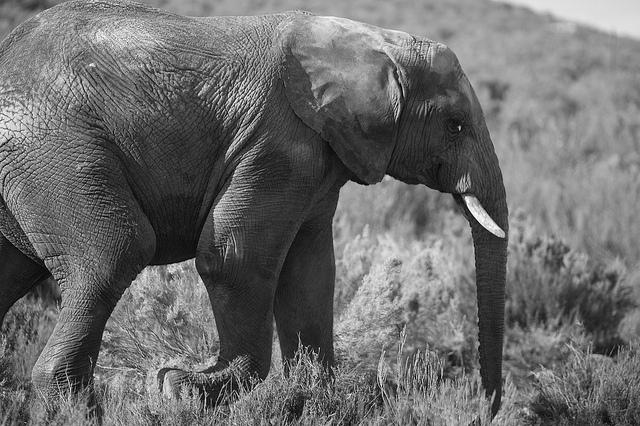What kind of enclosure is the elephant in?
Concise answer only. Zoo. What animal is this?
Keep it brief. Elephant. Is this elephant walking or standing still?
Give a very brief answer. Walking. Is elephant in the wilds or in a zoo?
Keep it brief. Wild. How many chopped tree trunks are shown in front of the elephant?
Keep it brief. 0. 